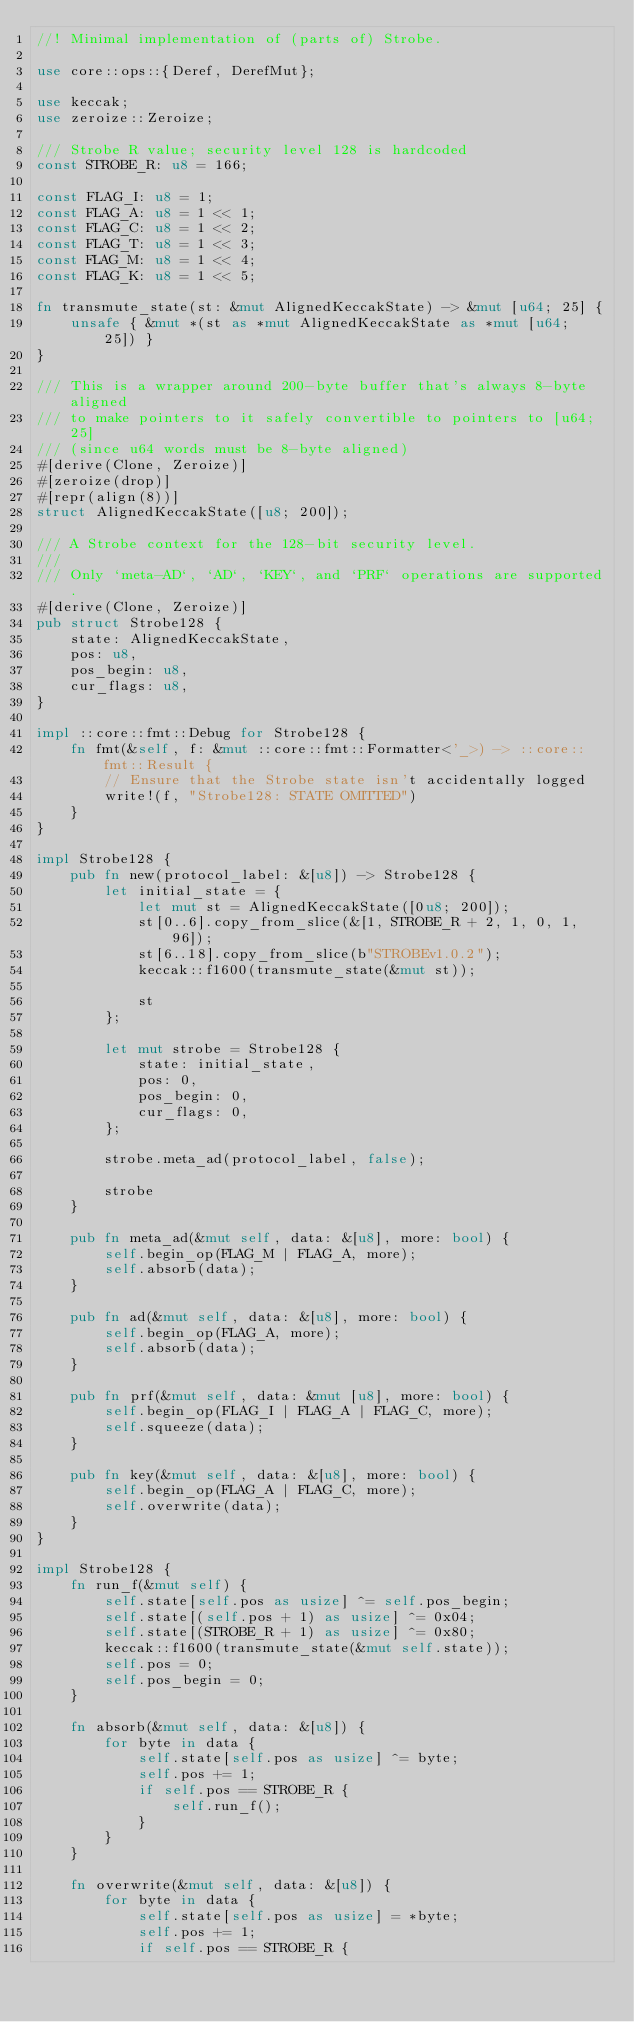Convert code to text. <code><loc_0><loc_0><loc_500><loc_500><_Rust_>//! Minimal implementation of (parts of) Strobe.

use core::ops::{Deref, DerefMut};

use keccak;
use zeroize::Zeroize;

/// Strobe R value; security level 128 is hardcoded
const STROBE_R: u8 = 166;

const FLAG_I: u8 = 1;
const FLAG_A: u8 = 1 << 1;
const FLAG_C: u8 = 1 << 2;
const FLAG_T: u8 = 1 << 3;
const FLAG_M: u8 = 1 << 4;
const FLAG_K: u8 = 1 << 5;

fn transmute_state(st: &mut AlignedKeccakState) -> &mut [u64; 25] {
    unsafe { &mut *(st as *mut AlignedKeccakState as *mut [u64; 25]) }
}

/// This is a wrapper around 200-byte buffer that's always 8-byte aligned
/// to make pointers to it safely convertible to pointers to [u64; 25]
/// (since u64 words must be 8-byte aligned)
#[derive(Clone, Zeroize)]
#[zeroize(drop)]
#[repr(align(8))]
struct AlignedKeccakState([u8; 200]);

/// A Strobe context for the 128-bit security level.
///
/// Only `meta-AD`, `AD`, `KEY`, and `PRF` operations are supported.
#[derive(Clone, Zeroize)]
pub struct Strobe128 {
    state: AlignedKeccakState,
    pos: u8,
    pos_begin: u8,
    cur_flags: u8,
}

impl ::core::fmt::Debug for Strobe128 {
    fn fmt(&self, f: &mut ::core::fmt::Formatter<'_>) -> ::core::fmt::Result {
        // Ensure that the Strobe state isn't accidentally logged
        write!(f, "Strobe128: STATE OMITTED")
    }
}

impl Strobe128 {
    pub fn new(protocol_label: &[u8]) -> Strobe128 {
        let initial_state = {
            let mut st = AlignedKeccakState([0u8; 200]);
            st[0..6].copy_from_slice(&[1, STROBE_R + 2, 1, 0, 1, 96]);
            st[6..18].copy_from_slice(b"STROBEv1.0.2");
            keccak::f1600(transmute_state(&mut st));

            st
        };

        let mut strobe = Strobe128 {
            state: initial_state,
            pos: 0,
            pos_begin: 0,
            cur_flags: 0,
        };

        strobe.meta_ad(protocol_label, false);

        strobe
    }

    pub fn meta_ad(&mut self, data: &[u8], more: bool) {
        self.begin_op(FLAG_M | FLAG_A, more);
        self.absorb(data);
    }

    pub fn ad(&mut self, data: &[u8], more: bool) {
        self.begin_op(FLAG_A, more);
        self.absorb(data);
    }

    pub fn prf(&mut self, data: &mut [u8], more: bool) {
        self.begin_op(FLAG_I | FLAG_A | FLAG_C, more);
        self.squeeze(data);
    }

    pub fn key(&mut self, data: &[u8], more: bool) {
        self.begin_op(FLAG_A | FLAG_C, more);
        self.overwrite(data);
    }
}

impl Strobe128 {
    fn run_f(&mut self) {
        self.state[self.pos as usize] ^= self.pos_begin;
        self.state[(self.pos + 1) as usize] ^= 0x04;
        self.state[(STROBE_R + 1) as usize] ^= 0x80;
        keccak::f1600(transmute_state(&mut self.state));
        self.pos = 0;
        self.pos_begin = 0;
    }

    fn absorb(&mut self, data: &[u8]) {
        for byte in data {
            self.state[self.pos as usize] ^= byte;
            self.pos += 1;
            if self.pos == STROBE_R {
                self.run_f();
            }
        }
    }

    fn overwrite(&mut self, data: &[u8]) {
        for byte in data {
            self.state[self.pos as usize] = *byte;
            self.pos += 1;
            if self.pos == STROBE_R {</code> 